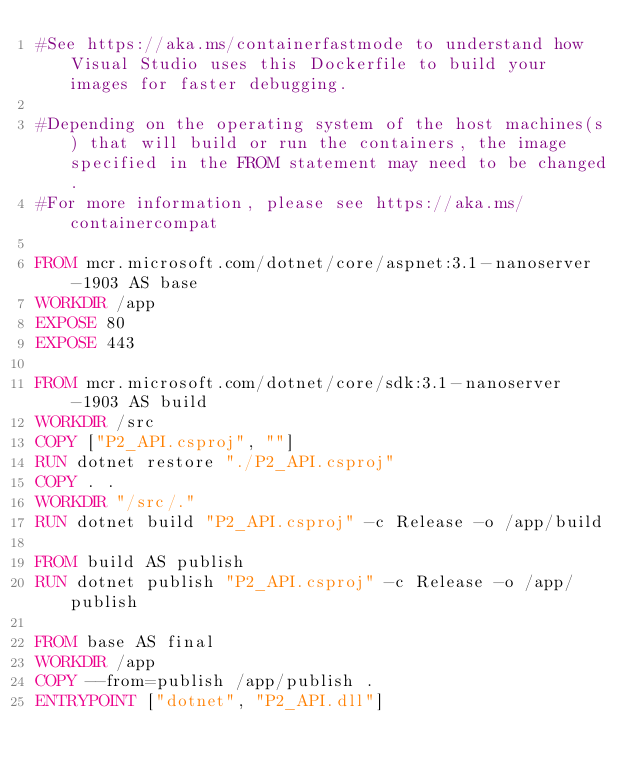Convert code to text. <code><loc_0><loc_0><loc_500><loc_500><_Dockerfile_>#See https://aka.ms/containerfastmode to understand how Visual Studio uses this Dockerfile to build your images for faster debugging.

#Depending on the operating system of the host machines(s) that will build or run the containers, the image specified in the FROM statement may need to be changed.
#For more information, please see https://aka.ms/containercompat

FROM mcr.microsoft.com/dotnet/core/aspnet:3.1-nanoserver-1903 AS base
WORKDIR /app
EXPOSE 80
EXPOSE 443

FROM mcr.microsoft.com/dotnet/core/sdk:3.1-nanoserver-1903 AS build
WORKDIR /src
COPY ["P2_API.csproj", ""]
RUN dotnet restore "./P2_API.csproj"
COPY . .
WORKDIR "/src/."
RUN dotnet build "P2_API.csproj" -c Release -o /app/build

FROM build AS publish
RUN dotnet publish "P2_API.csproj" -c Release -o /app/publish

FROM base AS final
WORKDIR /app
COPY --from=publish /app/publish .
ENTRYPOINT ["dotnet", "P2_API.dll"]</code> 